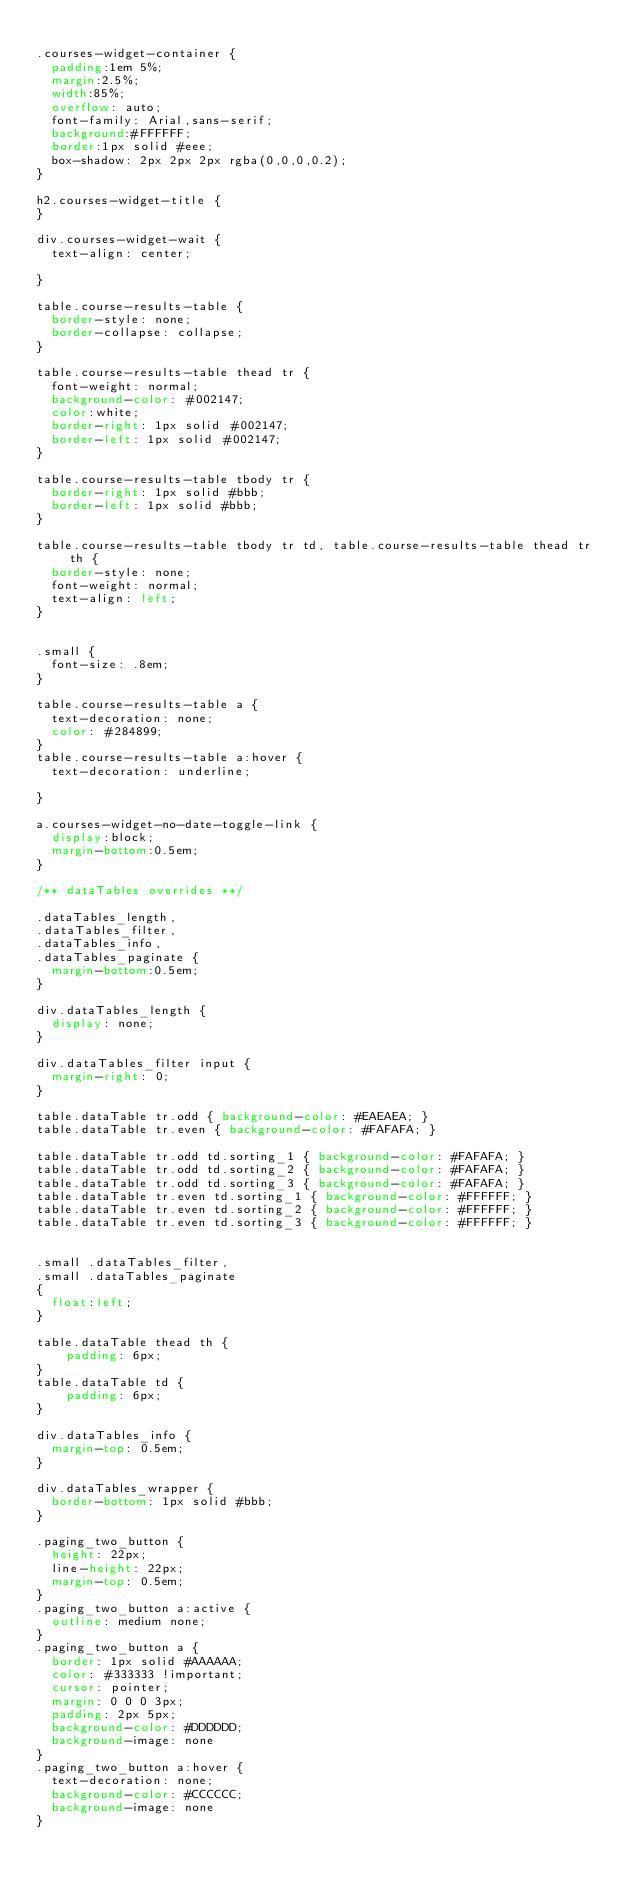Convert code to text. <code><loc_0><loc_0><loc_500><loc_500><_CSS_>
.courses-widget-container {
  padding:1em 5%;
  margin:2.5%;
  width:85%;
  overflow: auto;
  font-family: Arial,sans-serif;
  background:#FFFFFF;
  border:1px solid #eee;
  box-shadow: 2px 2px 2px rgba(0,0,0,0.2);
}

h2.courses-widget-title {
}

div.courses-widget-wait {
  text-align: center;

}

table.course-results-table { 
  border-style: none;
  border-collapse: collapse;
}

table.course-results-table thead tr {
  font-weight: normal;
  background-color: #002147;
  color:white;
  border-right: 1px solid #002147;
  border-left: 1px solid #002147;
}

table.course-results-table tbody tr {
  border-right: 1px solid #bbb;
  border-left: 1px solid #bbb;
}

table.course-results-table tbody tr td, table.course-results-table thead tr th {
  border-style: none;
  font-weight: normal;
  text-align: left;
}


.small {
  font-size: .8em;
}

table.course-results-table a {
  text-decoration: none;
  color: #284899;
}
table.course-results-table a:hover {
  text-decoration: underline;

}

a.courses-widget-no-date-toggle-link {
  display:block;
  margin-bottom:0.5em;
}

/** dataTables overrides **/

.dataTables_length,
.dataTables_filter,
.dataTables_info,
.dataTables_paginate {
  margin-bottom:0.5em;
}

div.dataTables_length {
  display: none;
}

div.dataTables_filter input {
  margin-right: 0;
}

table.dataTable tr.odd { background-color: #EAEAEA; }
table.dataTable tr.even { background-color: #FAFAFA; }

table.dataTable tr.odd td.sorting_1 { background-color: #FAFAFA; }
table.dataTable tr.odd td.sorting_2 { background-color: #FAFAFA; }
table.dataTable tr.odd td.sorting_3 { background-color: #FAFAFA; }
table.dataTable tr.even td.sorting_1 { background-color: #FFFFFF; }
table.dataTable tr.even td.sorting_2 { background-color: #FFFFFF; }
table.dataTable tr.even td.sorting_3 { background-color: #FFFFFF; }


.small .dataTables_filter,
.small .dataTables_paginate
{
  float:left;
}

table.dataTable thead th {
    padding: 6px;
}
table.dataTable td {
    padding: 6px;
}

div.dataTables_info {
  margin-top: 0.5em;
}

div.dataTables_wrapper {
  border-bottom: 1px solid #bbb;
}

.paging_two_button {
  height: 22px;
  line-height: 22px;
  margin-top: 0.5em;
}
.paging_two_button a:active {
  outline: medium none;
}
.paging_two_button a {
  border: 1px solid #AAAAAA;
  color: #333333 !important;
  cursor: pointer;
  margin: 0 0 0 3px;
  padding: 2px 5px;
  background-color: #DDDDDD;
  background-image: none
}
.paging_two_button a:hover {
  text-decoration: none;
  background-color: #CCCCCC;
  background-image: none
}
</code> 